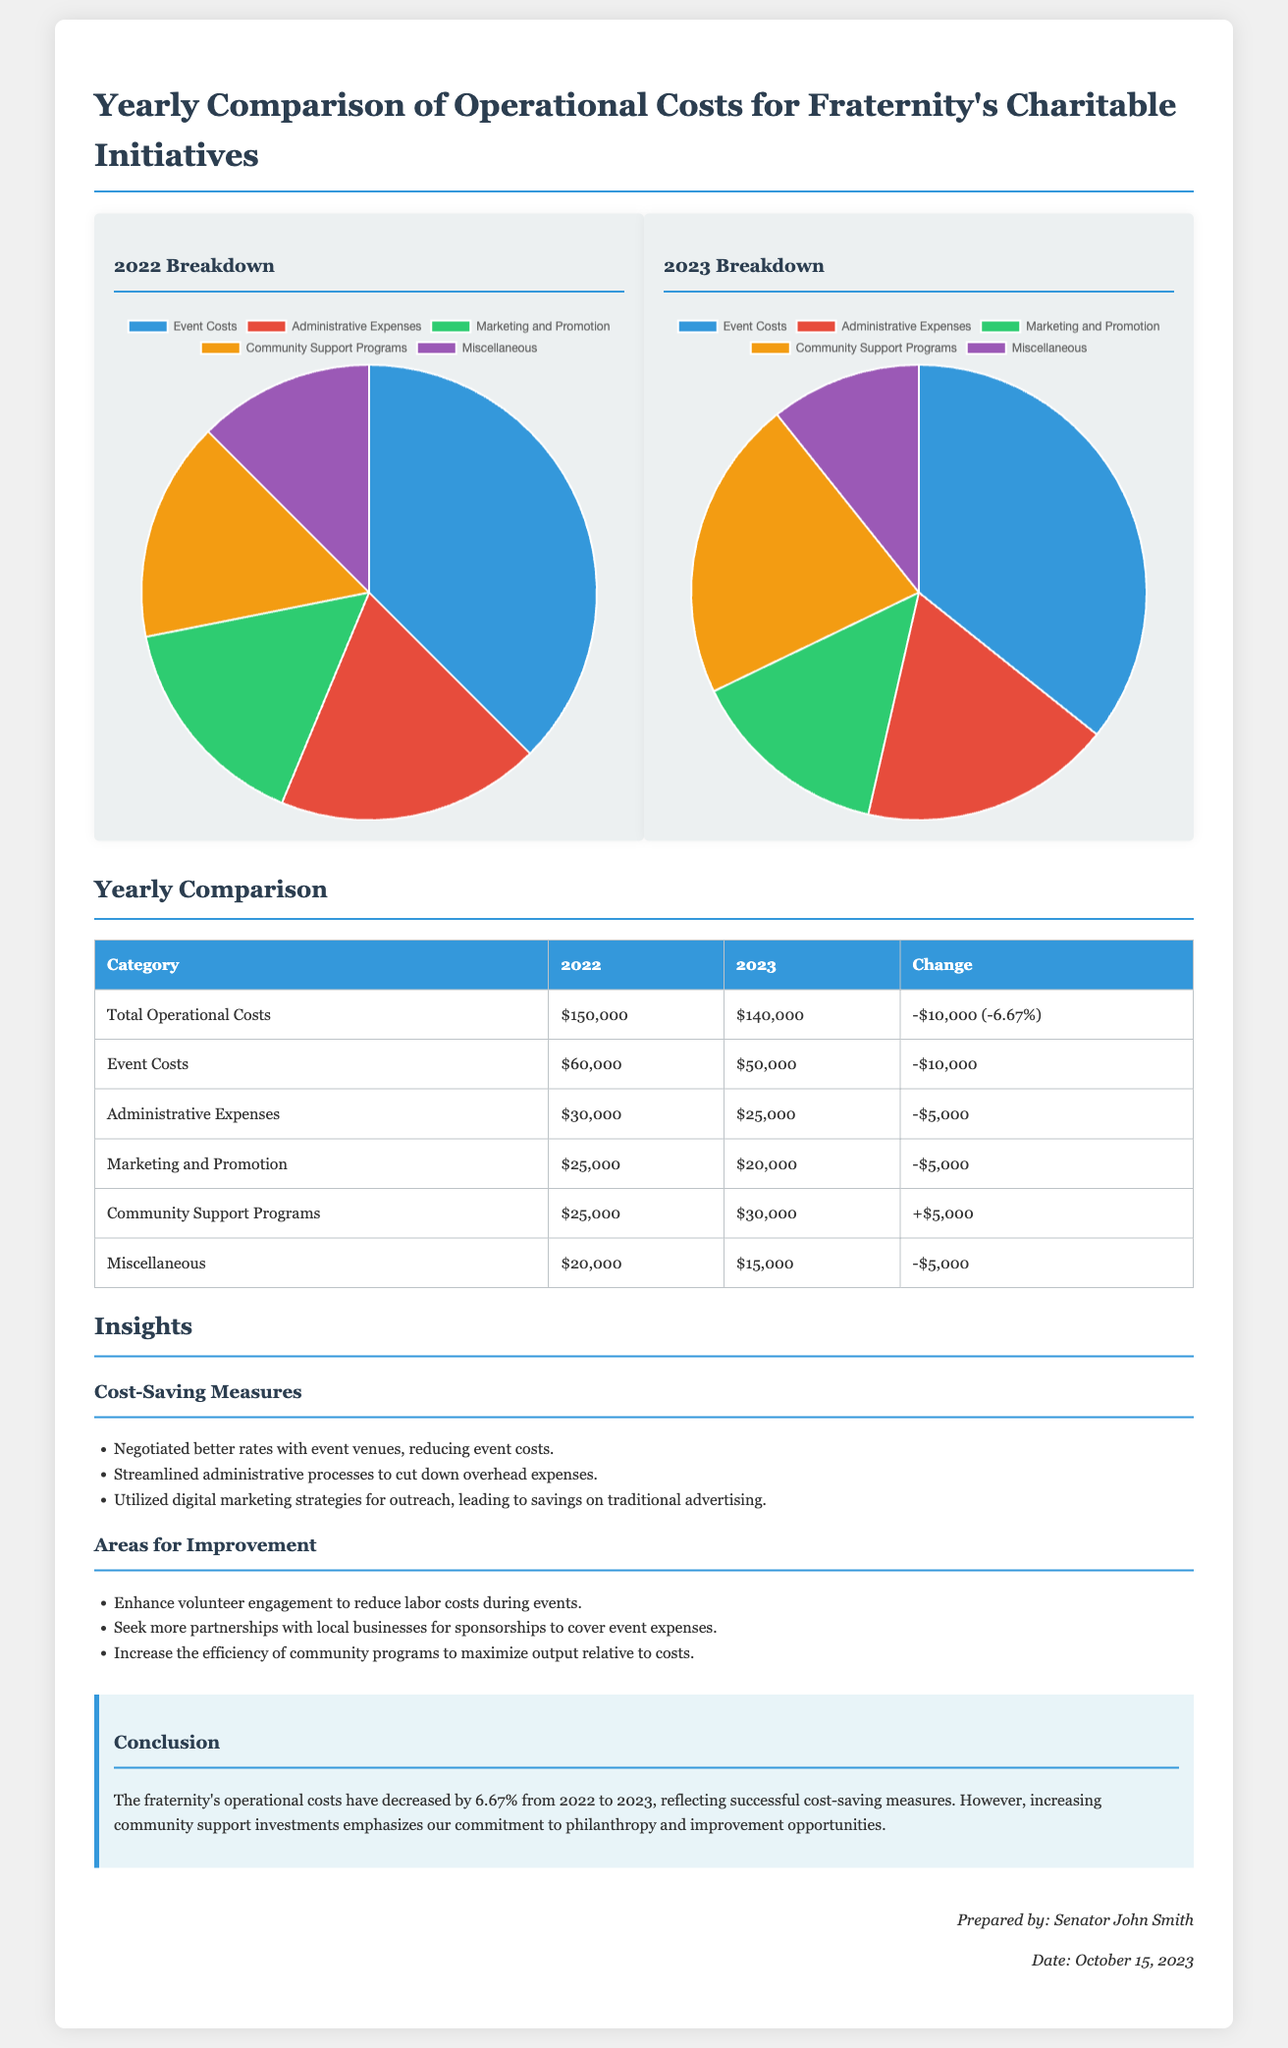What were the total operational costs in 2022? The total operational costs in 2022 are listed in the comparison table as $150,000.
Answer: $150,000 What was the percentage change in total operational costs from 2022 to 2023? The table indicates a decrease in total operational costs by $10,000, which is -6.67%.
Answer: -6.67% How much did the administrative expenses decrease from 2022 to 2023? The document notes that administrative expenses decreased from $30,000 to $25,000, making it a reduction of $5,000.
Answer: $5,000 What was the cost for community support programs in 2023? According to the table, the cost for community support programs in 2023 is $30,000.
Answer: $30,000 What strategy contributed to reduced event costs? The insights section mentions that better rates were negotiated with event venues as a cost-saving measure.
Answer: Negotiated better rates What is an area identified for improvement regarding community programs? The areas for improvement section states that increasing the efficiency of community programs is necessary to maximize output relative to costs.
Answer: Increase efficiency What were the marketing and promotion costs in 2022? The costs for marketing and promotion are detailed in the table, showing $25,000 for 2022.
Answer: $25,000 How much did the fraternity spend on miscellaneous items in 2023? The document specifies that miscellaneous expenses were $15,000 in 2023.
Answer: $15,000 Who prepared the financial report? The signature section indicates that the financial report was prepared by Senator John Smith.
Answer: Senator John Smith 